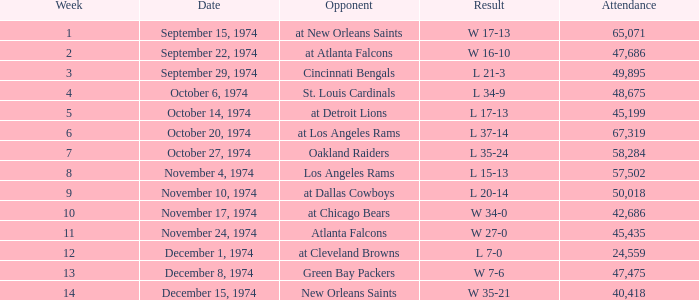For games played by the atlanta falcons, what was the average number of attendees? 47686.0. 